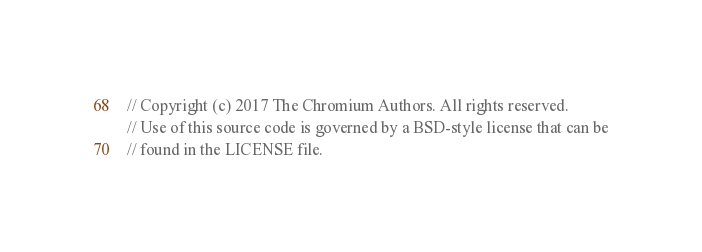Convert code to text. <code><loc_0><loc_0><loc_500><loc_500><_C_>// Copyright (c) 2017 The Chromium Authors. All rights reserved.
// Use of this source code is governed by a BSD-style license that can be
// found in the LICENSE file.
</code> 